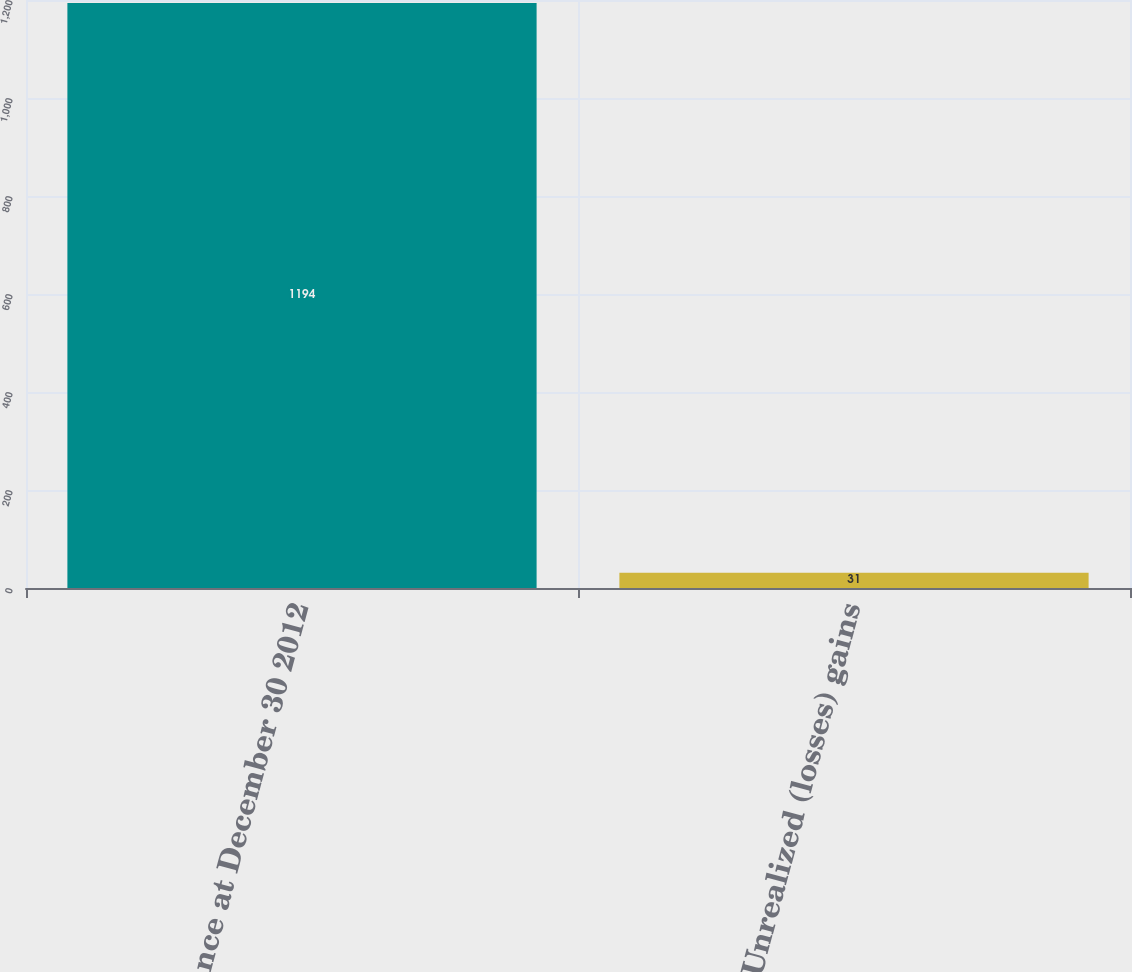Convert chart to OTSL. <chart><loc_0><loc_0><loc_500><loc_500><bar_chart><fcel>Balance at December 30 2012<fcel>Unrealized (losses) gains<nl><fcel>1194<fcel>31<nl></chart> 